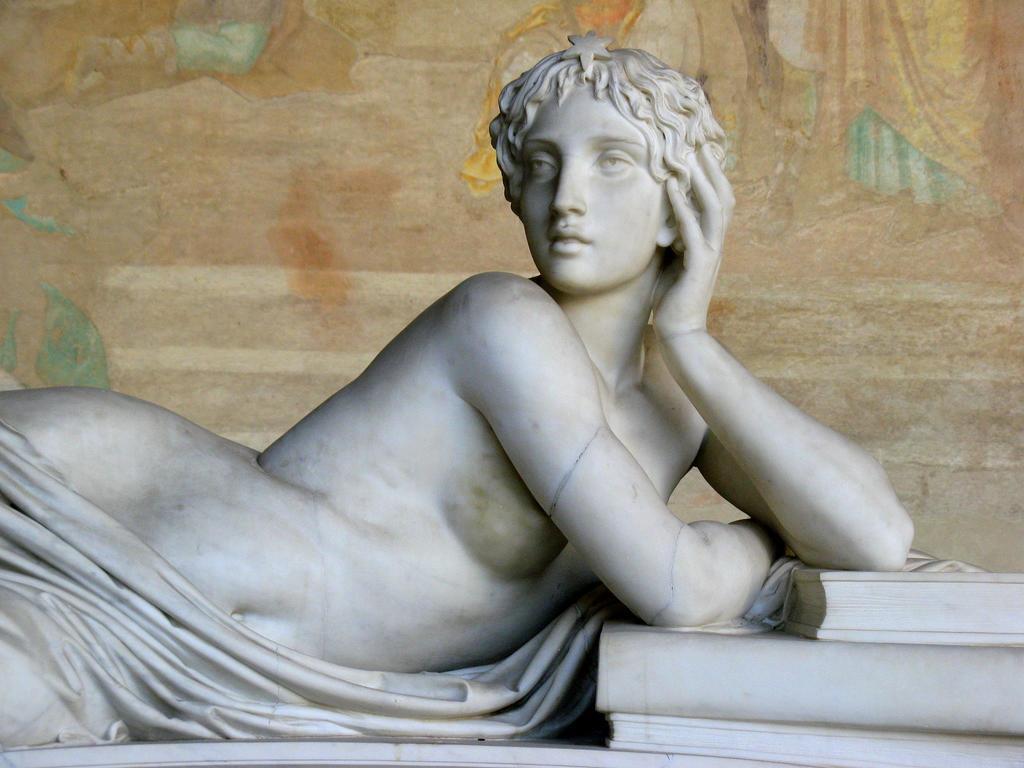Please provide a concise description of this image. In this image we can see statue of a person and books. In the background we can see painting on the wall. 